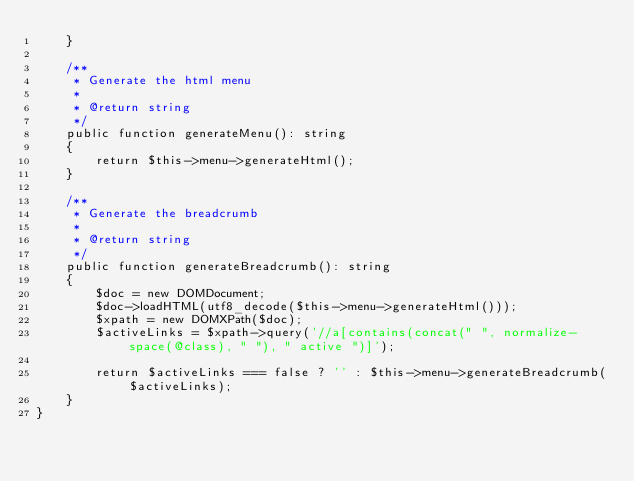Convert code to text. <code><loc_0><loc_0><loc_500><loc_500><_PHP_>    }

    /**
     * Generate the html menu
     *
     * @return string
     */
    public function generateMenu(): string
    {
        return $this->menu->generateHtml();
    }

    /**
     * Generate the breadcrumb
     *
     * @return string
     */
    public function generateBreadcrumb(): string
    {
        $doc = new DOMDocument;
        $doc->loadHTML(utf8_decode($this->menu->generateHtml()));
        $xpath = new DOMXPath($doc);
        $activeLinks = $xpath->query('//a[contains(concat(" ", normalize-space(@class), " "), " active ")]');

        return $activeLinks === false ? '' : $this->menu->generateBreadcrumb($activeLinks);
    }
}
</code> 